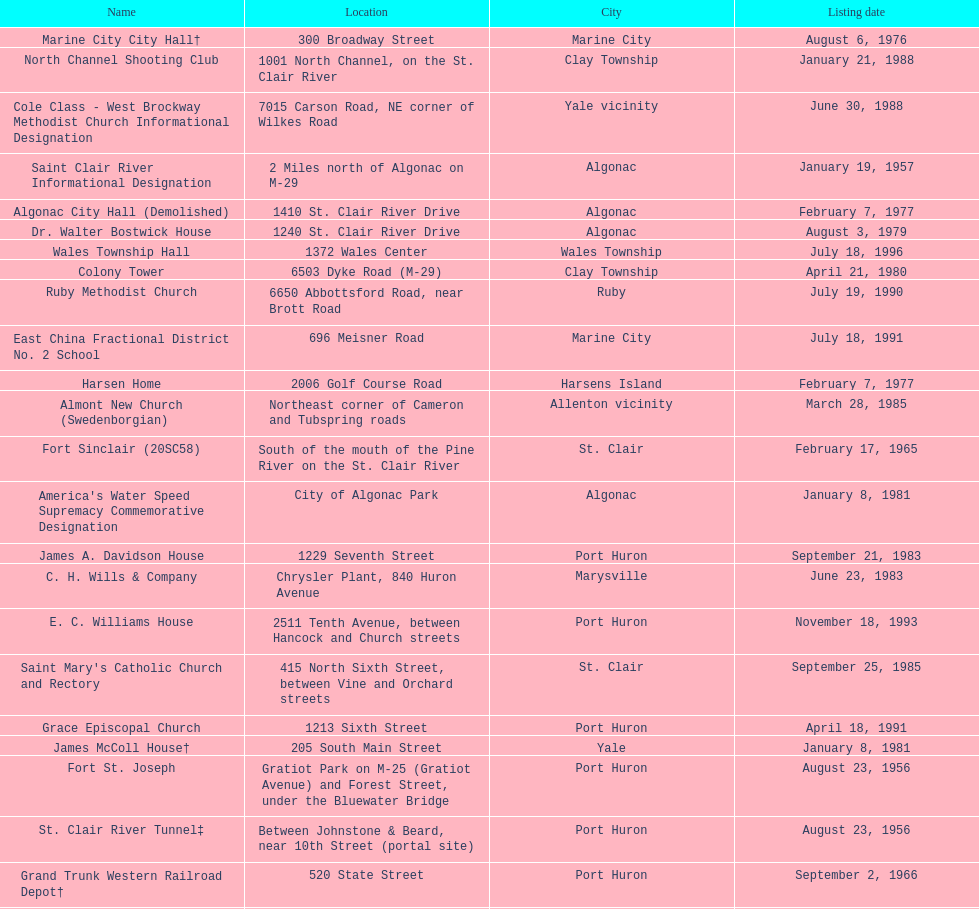What is the total number of locations in the city of algonac? 5. 